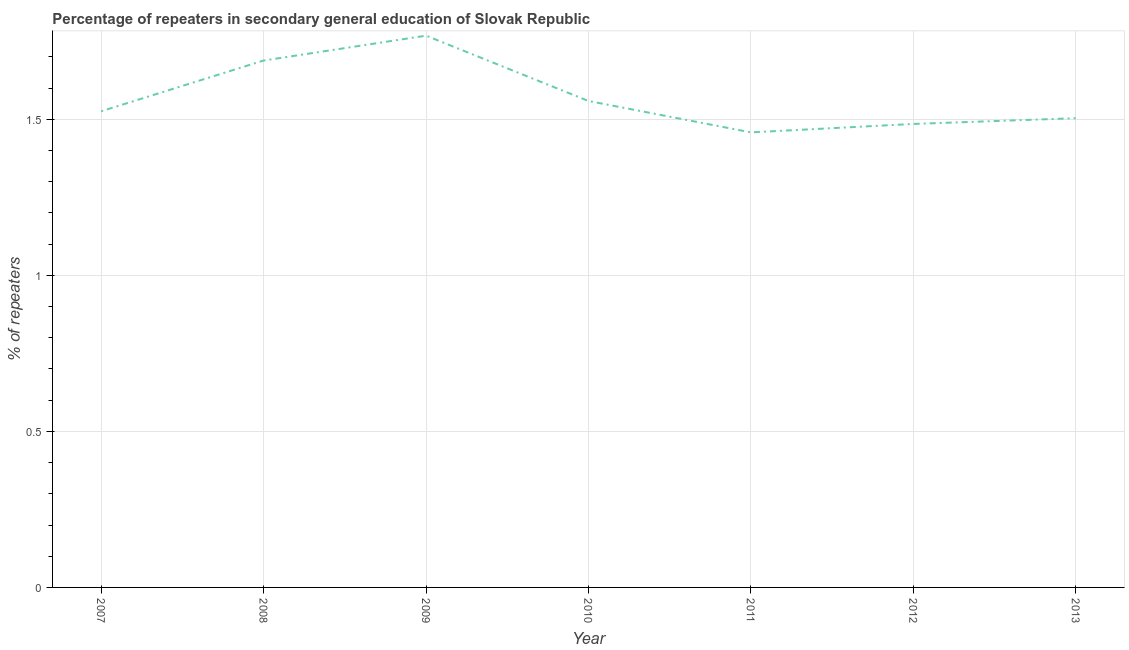What is the percentage of repeaters in 2009?
Provide a succinct answer. 1.77. Across all years, what is the maximum percentage of repeaters?
Make the answer very short. 1.77. Across all years, what is the minimum percentage of repeaters?
Give a very brief answer. 1.46. In which year was the percentage of repeaters maximum?
Ensure brevity in your answer.  2009. What is the sum of the percentage of repeaters?
Offer a terse response. 10.99. What is the difference between the percentage of repeaters in 2008 and 2011?
Your answer should be compact. 0.23. What is the average percentage of repeaters per year?
Give a very brief answer. 1.57. What is the median percentage of repeaters?
Your answer should be compact. 1.53. In how many years, is the percentage of repeaters greater than 0.7 %?
Ensure brevity in your answer.  7. What is the ratio of the percentage of repeaters in 2008 to that in 2010?
Provide a succinct answer. 1.08. Is the difference between the percentage of repeaters in 2007 and 2009 greater than the difference between any two years?
Your answer should be compact. No. What is the difference between the highest and the second highest percentage of repeaters?
Provide a short and direct response. 0.08. Is the sum of the percentage of repeaters in 2007 and 2011 greater than the maximum percentage of repeaters across all years?
Offer a terse response. Yes. What is the difference between the highest and the lowest percentage of repeaters?
Ensure brevity in your answer.  0.31. In how many years, is the percentage of repeaters greater than the average percentage of repeaters taken over all years?
Provide a succinct answer. 2. How many lines are there?
Keep it short and to the point. 1. How many years are there in the graph?
Ensure brevity in your answer.  7. Does the graph contain any zero values?
Give a very brief answer. No. What is the title of the graph?
Keep it short and to the point. Percentage of repeaters in secondary general education of Slovak Republic. What is the label or title of the X-axis?
Make the answer very short. Year. What is the label or title of the Y-axis?
Provide a short and direct response. % of repeaters. What is the % of repeaters of 2007?
Make the answer very short. 1.53. What is the % of repeaters in 2008?
Make the answer very short. 1.69. What is the % of repeaters of 2009?
Ensure brevity in your answer.  1.77. What is the % of repeaters in 2010?
Your answer should be very brief. 1.56. What is the % of repeaters in 2011?
Offer a terse response. 1.46. What is the % of repeaters of 2012?
Ensure brevity in your answer.  1.49. What is the % of repeaters of 2013?
Provide a short and direct response. 1.5. What is the difference between the % of repeaters in 2007 and 2008?
Your response must be concise. -0.16. What is the difference between the % of repeaters in 2007 and 2009?
Your answer should be very brief. -0.24. What is the difference between the % of repeaters in 2007 and 2010?
Give a very brief answer. -0.03. What is the difference between the % of repeaters in 2007 and 2011?
Provide a succinct answer. 0.07. What is the difference between the % of repeaters in 2007 and 2012?
Offer a terse response. 0.04. What is the difference between the % of repeaters in 2007 and 2013?
Provide a short and direct response. 0.02. What is the difference between the % of repeaters in 2008 and 2009?
Provide a short and direct response. -0.08. What is the difference between the % of repeaters in 2008 and 2010?
Make the answer very short. 0.13. What is the difference between the % of repeaters in 2008 and 2011?
Provide a succinct answer. 0.23. What is the difference between the % of repeaters in 2008 and 2012?
Ensure brevity in your answer.  0.2. What is the difference between the % of repeaters in 2008 and 2013?
Offer a very short reply. 0.18. What is the difference between the % of repeaters in 2009 and 2010?
Give a very brief answer. 0.21. What is the difference between the % of repeaters in 2009 and 2011?
Provide a succinct answer. 0.31. What is the difference between the % of repeaters in 2009 and 2012?
Your answer should be compact. 0.28. What is the difference between the % of repeaters in 2009 and 2013?
Offer a very short reply. 0.26. What is the difference between the % of repeaters in 2010 and 2011?
Your answer should be very brief. 0.1. What is the difference between the % of repeaters in 2010 and 2012?
Ensure brevity in your answer.  0.07. What is the difference between the % of repeaters in 2010 and 2013?
Give a very brief answer. 0.06. What is the difference between the % of repeaters in 2011 and 2012?
Your answer should be very brief. -0.03. What is the difference between the % of repeaters in 2011 and 2013?
Ensure brevity in your answer.  -0.05. What is the difference between the % of repeaters in 2012 and 2013?
Give a very brief answer. -0.02. What is the ratio of the % of repeaters in 2007 to that in 2008?
Offer a terse response. 0.9. What is the ratio of the % of repeaters in 2007 to that in 2009?
Give a very brief answer. 0.86. What is the ratio of the % of repeaters in 2007 to that in 2010?
Offer a very short reply. 0.98. What is the ratio of the % of repeaters in 2007 to that in 2011?
Your response must be concise. 1.05. What is the ratio of the % of repeaters in 2007 to that in 2012?
Make the answer very short. 1.03. What is the ratio of the % of repeaters in 2008 to that in 2009?
Provide a succinct answer. 0.95. What is the ratio of the % of repeaters in 2008 to that in 2010?
Give a very brief answer. 1.08. What is the ratio of the % of repeaters in 2008 to that in 2011?
Your response must be concise. 1.16. What is the ratio of the % of repeaters in 2008 to that in 2012?
Offer a terse response. 1.14. What is the ratio of the % of repeaters in 2008 to that in 2013?
Your answer should be compact. 1.12. What is the ratio of the % of repeaters in 2009 to that in 2010?
Offer a very short reply. 1.13. What is the ratio of the % of repeaters in 2009 to that in 2011?
Offer a very short reply. 1.21. What is the ratio of the % of repeaters in 2009 to that in 2012?
Give a very brief answer. 1.19. What is the ratio of the % of repeaters in 2009 to that in 2013?
Give a very brief answer. 1.18. What is the ratio of the % of repeaters in 2010 to that in 2011?
Your response must be concise. 1.07. What is the ratio of the % of repeaters in 2011 to that in 2012?
Provide a short and direct response. 0.98. What is the ratio of the % of repeaters in 2011 to that in 2013?
Make the answer very short. 0.97. 